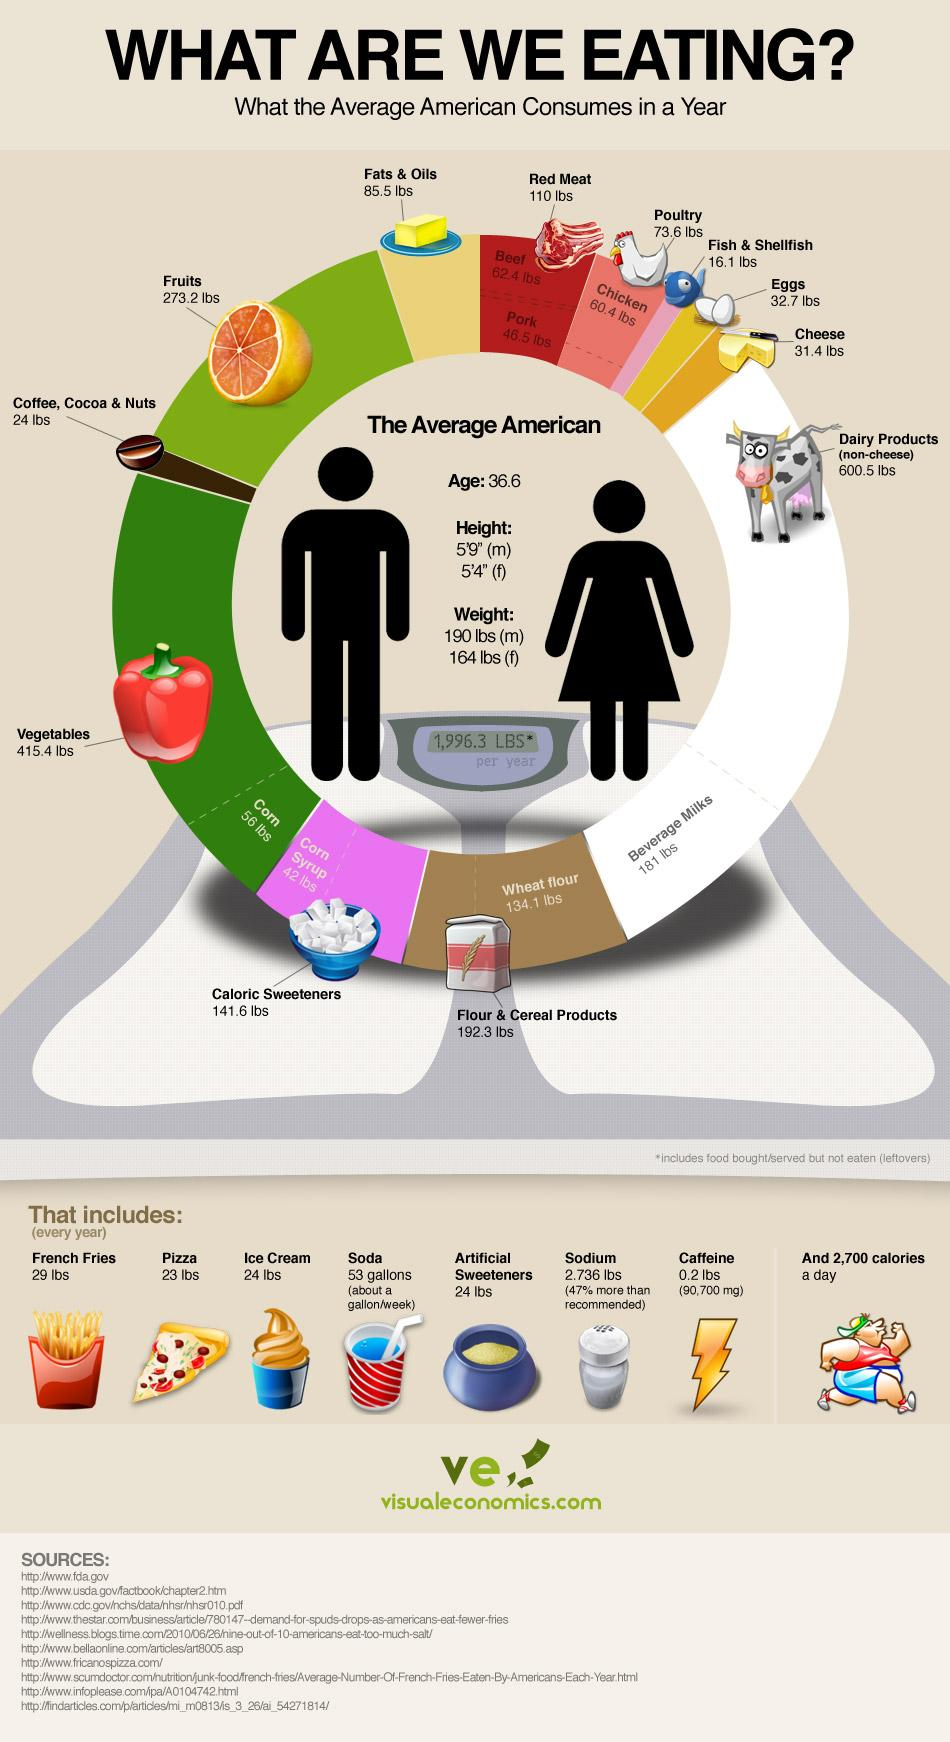List a handful of essential elements in this visual. The weekly consumption of soda is approximately a gallon. The color of capsicum is red. The average height of an American female is 5 feet and 4 inches. According to data, the average American consumes approximately 106.3 pounds of eggs and poultry in a year. The average height of an American male is 5 feet and 9 inches. 